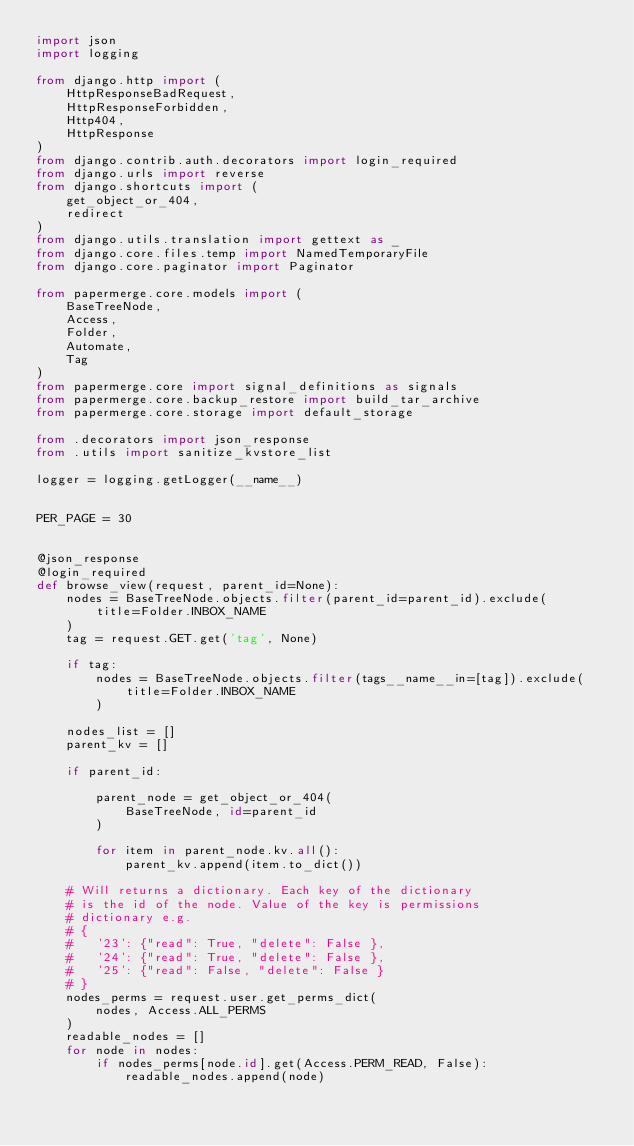Convert code to text. <code><loc_0><loc_0><loc_500><loc_500><_Python_>import json
import logging

from django.http import (
    HttpResponseBadRequest,
    HttpResponseForbidden,
    Http404,
    HttpResponse
)
from django.contrib.auth.decorators import login_required
from django.urls import reverse
from django.shortcuts import (
    get_object_or_404,
    redirect
)
from django.utils.translation import gettext as _
from django.core.files.temp import NamedTemporaryFile
from django.core.paginator import Paginator

from papermerge.core.models import (
    BaseTreeNode,
    Access,
    Folder,
    Automate,
    Tag
)
from papermerge.core import signal_definitions as signals
from papermerge.core.backup_restore import build_tar_archive
from papermerge.core.storage import default_storage

from .decorators import json_response
from .utils import sanitize_kvstore_list

logger = logging.getLogger(__name__)


PER_PAGE = 30


@json_response
@login_required
def browse_view(request, parent_id=None):
    nodes = BaseTreeNode.objects.filter(parent_id=parent_id).exclude(
        title=Folder.INBOX_NAME
    )
    tag = request.GET.get('tag', None)

    if tag:
        nodes = BaseTreeNode.objects.filter(tags__name__in=[tag]).exclude(
            title=Folder.INBOX_NAME
        )

    nodes_list = []
    parent_kv = []

    if parent_id:

        parent_node = get_object_or_404(
            BaseTreeNode, id=parent_id
        )

        for item in parent_node.kv.all():
            parent_kv.append(item.to_dict())

    # Will returns a dictionary. Each key of the dictionary
    # is the id of the node. Value of the key is permissions
    # dictionary e.g.
    # {
    #   '23': {"read": True, "delete": False },
    #   '24': {"read": True, "delete": False },
    #   '25': {"read": False, "delete": False }
    # }
    nodes_perms = request.user.get_perms_dict(
        nodes, Access.ALL_PERMS
    )
    readable_nodes = []
    for node in nodes:
        if nodes_perms[node.id].get(Access.PERM_READ, False):
            readable_nodes.append(node)
</code> 